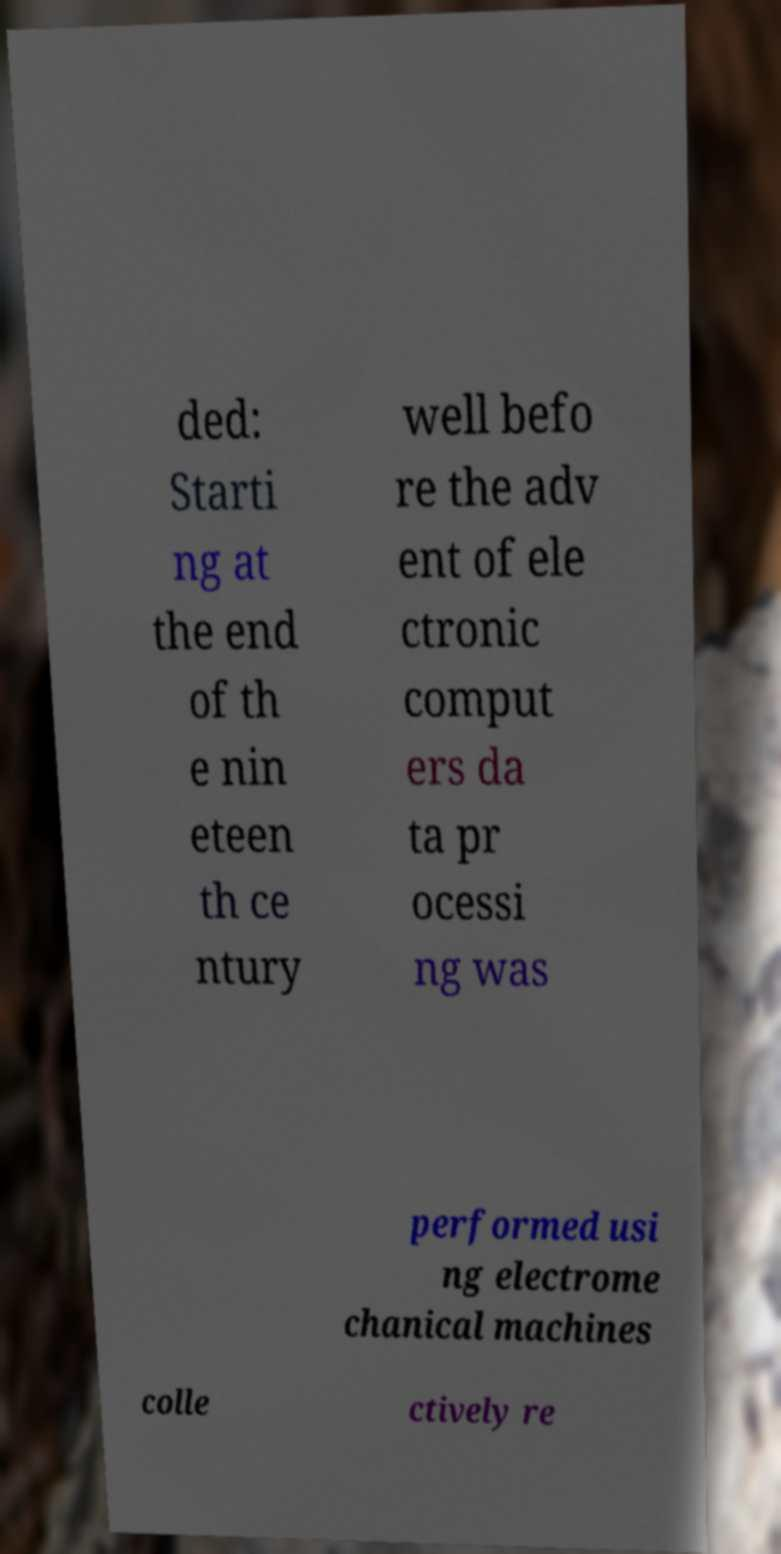Could you assist in decoding the text presented in this image and type it out clearly? ded: Starti ng at the end of th e nin eteen th ce ntury well befo re the adv ent of ele ctronic comput ers da ta pr ocessi ng was performed usi ng electrome chanical machines colle ctively re 